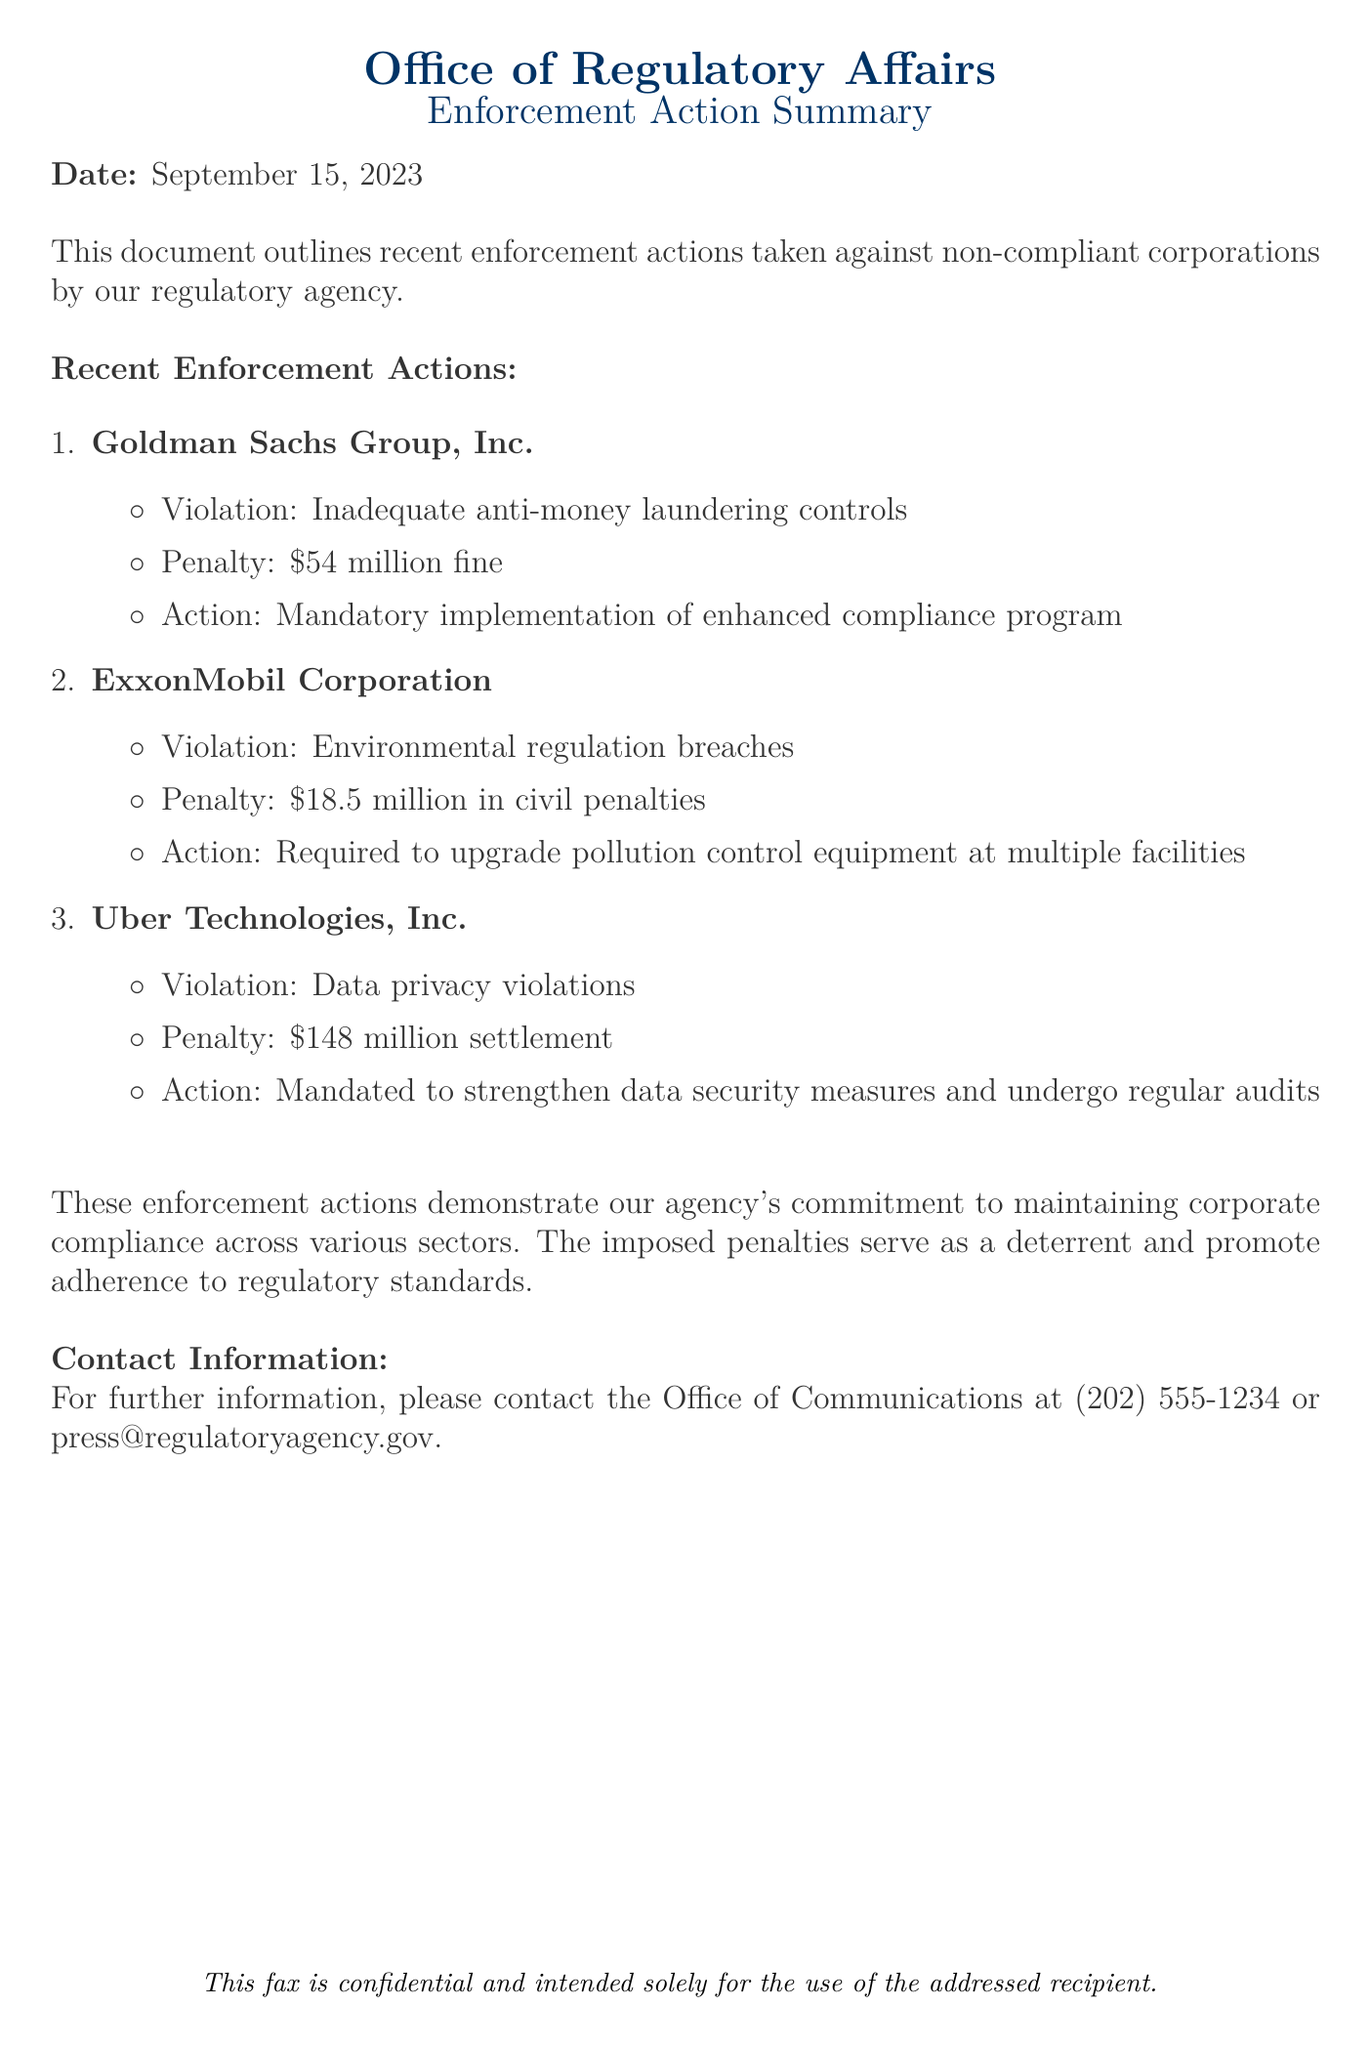What is the date of the document? The date mentioned in the document is clearly stated at the beginning as September 15, 2023.
Answer: September 15, 2023 What corporation was fined for inadequate anti-money laundering controls? The document specifies that Goldman Sachs Group, Inc. was found to have inadequate anti-money laundering controls.
Answer: Goldman Sachs Group, Inc What was the penalty imposed on Uber Technologies, Inc.? The document details that Uber Technologies, Inc. faced a penalty of $148 million settlement for data privacy violations.
Answer: $148 million settlement How much was the civil penalty on ExxonMobil Corporation? The document indicates a civil penalty amount of $18.5 million imposed on ExxonMobil Corporation for environmental regulation breaches.
Answer: $18.5 million What action was mandated for Goldman Sachs Group, Inc.? The document states that Goldman Sachs is required to implement an enhanced compliance program as part of the enforcement action.
Answer: Implementation of enhanced compliance program Which corporation was required to upgrade pollution control equipment? The document highlights that ExxonMobil Corporation was required to upgrade pollution control equipment at multiple facilities.
Answer: ExxonMobil Corporation What is emphasized at the end of the document regarding enforcement actions? The conclusion of the document highlights the agency's commitment to maintaining corporate compliance across various sectors through these enforcement actions.
Answer: Commitment to maintaining corporate compliance Who should be contacted for further information? The contact information listed at the end of the document is for the Office of Communications, which can be reached at (202) 555-1234 or press@regulatoryagency.gov.
Answer: Office of Communications 